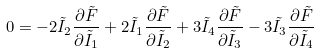Convert formula to latex. <formula><loc_0><loc_0><loc_500><loc_500>0 = - 2 \tilde { I } _ { 2 } \frac { \partial \tilde { F } } { \partial \tilde { I } _ { 1 } } + 2 \tilde { I } _ { 1 } \frac { \partial \tilde { F } } { \partial \tilde { I } _ { 2 } } + 3 \tilde { I } _ { 4 } \frac { \partial \tilde { F } } { \partial \tilde { I } _ { 3 } } - 3 \tilde { I } _ { 3 } \frac { \partial \tilde { F } } { \partial \tilde { I } _ { 4 } }</formula> 